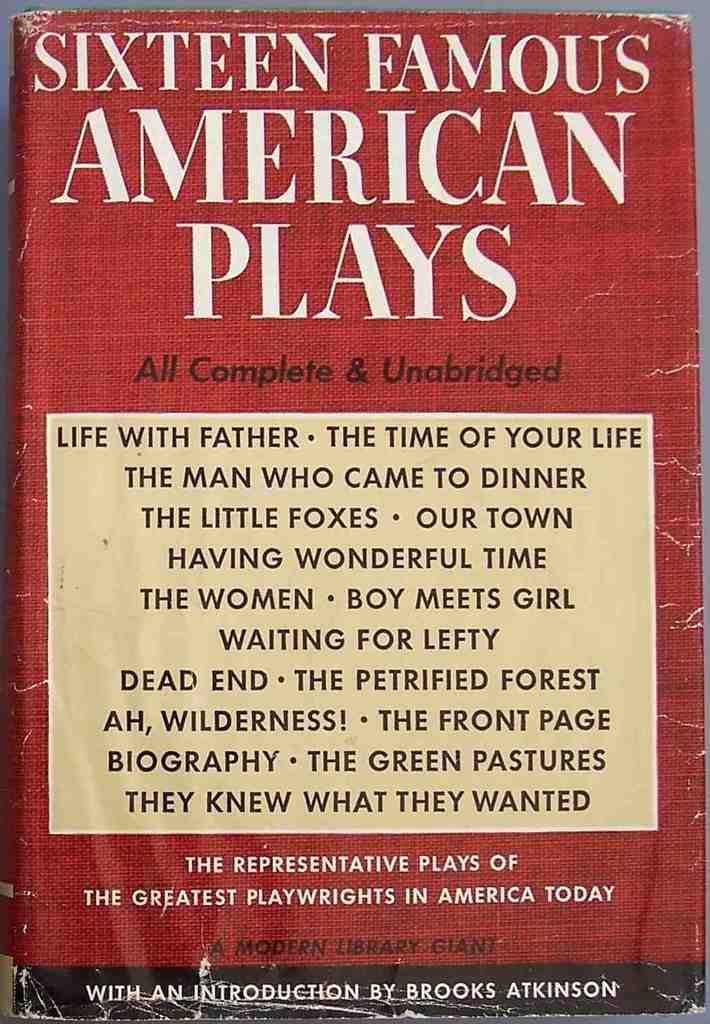How many plays are in this book?
Give a very brief answer. Sixteen. 